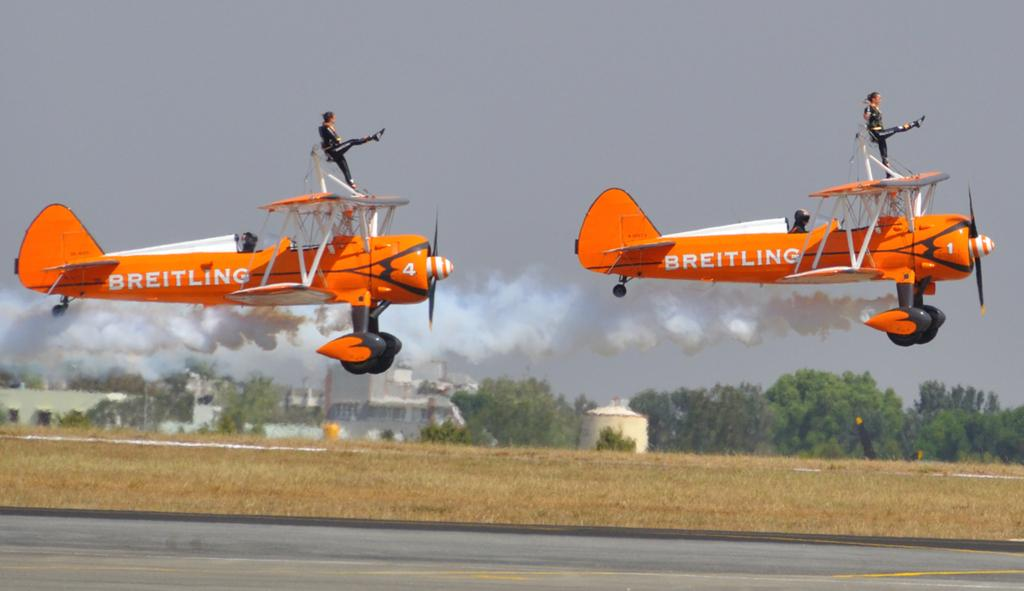Provide a one-sentence caption for the provided image. Two small orange and white Breitling planes taking off on a runway. 